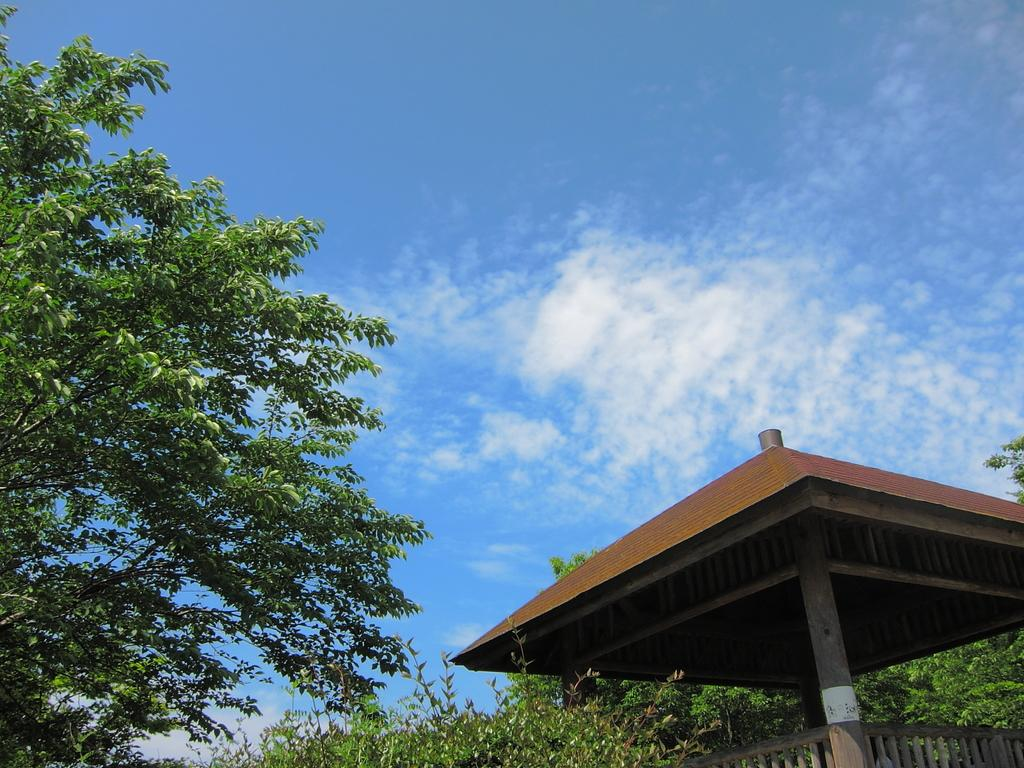What type of vegetation can be seen in the image? There are trees in the image. What architectural features are present in the image? There are pillars and a railing in the image. What part of a building can be seen in the image? There is a roof top in the image. What is visible in the background of the image? The sky is visible in the background of the image, and there are clouds in the sky. Can you see your aunt sitting on a nest in the image? There is no aunt or nest present in the image. What type of hall is visible in the image? There is no hall present in the image. 